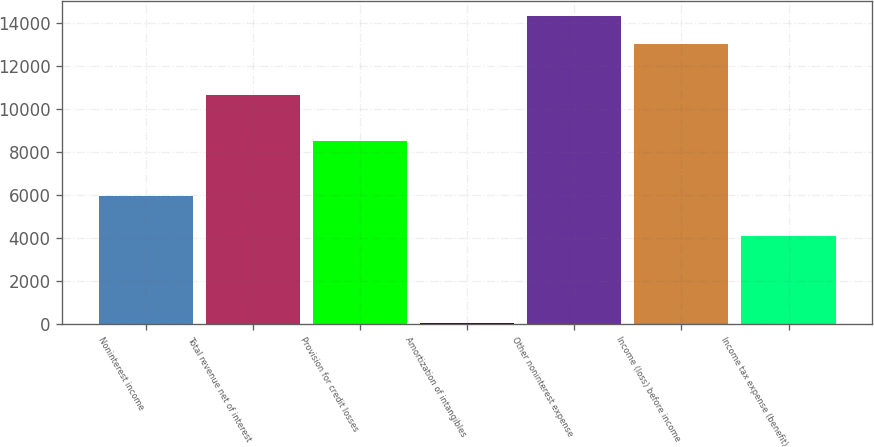Convert chart. <chart><loc_0><loc_0><loc_500><loc_500><bar_chart><fcel>Noninterest income<fcel>Total revenue net of interest<fcel>Provision for credit losses<fcel>Amortization of intangibles<fcel>Other noninterest expense<fcel>Income (loss) before income<fcel>Income tax expense (benefit)<nl><fcel>5957<fcel>10647<fcel>8490<fcel>38<fcel>14314.7<fcel>13006<fcel>4085<nl></chart> 